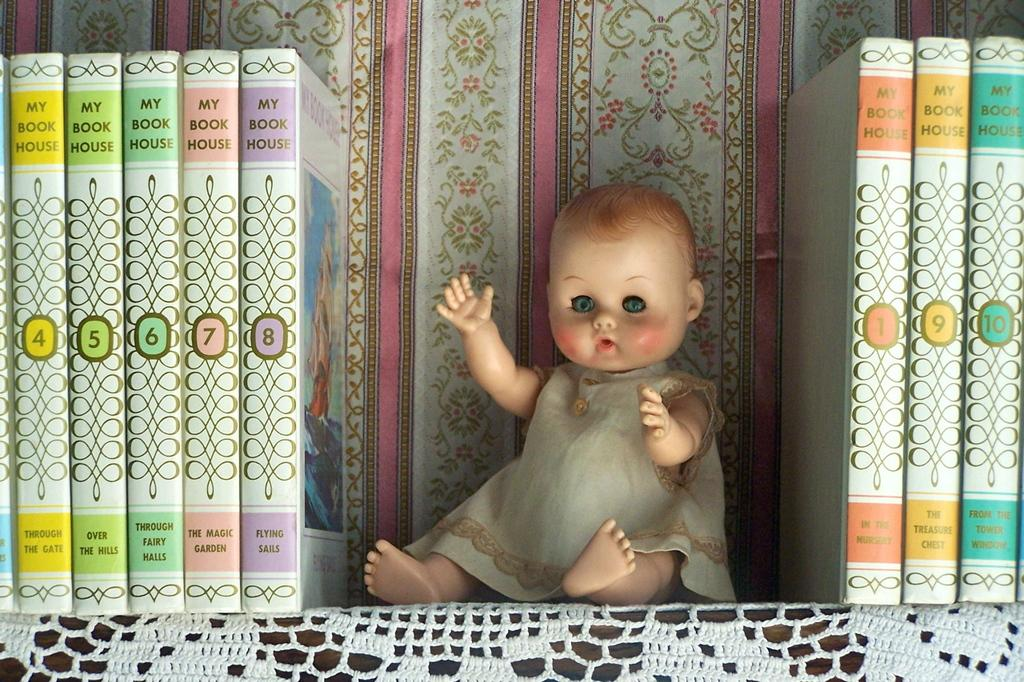<image>
Summarize the visual content of the image. Several different volumes of My Book House are on either side of a baby doll. 